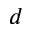Convert formula to latex. <formula><loc_0><loc_0><loc_500><loc_500>d</formula> 